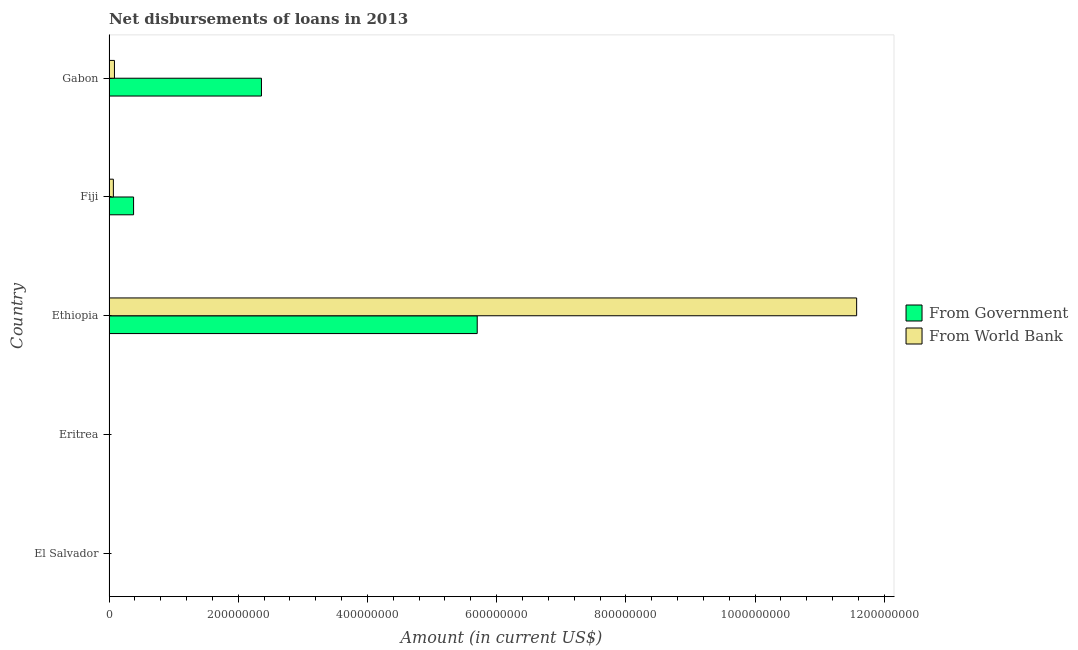Are the number of bars per tick equal to the number of legend labels?
Make the answer very short. No. Are the number of bars on each tick of the Y-axis equal?
Offer a very short reply. No. How many bars are there on the 3rd tick from the top?
Keep it short and to the point. 2. How many bars are there on the 1st tick from the bottom?
Provide a short and direct response. 0. What is the label of the 1st group of bars from the top?
Offer a very short reply. Gabon. In how many cases, is the number of bars for a given country not equal to the number of legend labels?
Your answer should be very brief. 2. Across all countries, what is the maximum net disbursements of loan from government?
Ensure brevity in your answer.  5.70e+08. In which country was the net disbursements of loan from world bank maximum?
Your answer should be compact. Ethiopia. What is the total net disbursements of loan from government in the graph?
Provide a short and direct response. 8.44e+08. What is the difference between the net disbursements of loan from world bank in Fiji and that in Gabon?
Provide a short and direct response. -1.68e+06. What is the difference between the net disbursements of loan from government in Fiji and the net disbursements of loan from world bank in Ethiopia?
Your response must be concise. -1.12e+09. What is the average net disbursements of loan from world bank per country?
Offer a terse response. 2.34e+08. What is the difference between the net disbursements of loan from world bank and net disbursements of loan from government in Ethiopia?
Give a very brief answer. 5.87e+08. What is the ratio of the net disbursements of loan from world bank in Fiji to that in Gabon?
Your answer should be very brief. 0.8. What is the difference between the highest and the second highest net disbursements of loan from world bank?
Ensure brevity in your answer.  1.15e+09. What is the difference between the highest and the lowest net disbursements of loan from government?
Your answer should be compact. 5.70e+08. In how many countries, is the net disbursements of loan from world bank greater than the average net disbursements of loan from world bank taken over all countries?
Keep it short and to the point. 1. Does the graph contain any zero values?
Provide a short and direct response. Yes. Does the graph contain grids?
Give a very brief answer. No. How many legend labels are there?
Provide a succinct answer. 2. What is the title of the graph?
Provide a succinct answer. Net disbursements of loans in 2013. What is the label or title of the Y-axis?
Keep it short and to the point. Country. What is the Amount (in current US$) in From Government in El Salvador?
Offer a terse response. 0. What is the Amount (in current US$) in From Government in Eritrea?
Provide a short and direct response. 0. What is the Amount (in current US$) of From World Bank in Eritrea?
Make the answer very short. 0. What is the Amount (in current US$) in From Government in Ethiopia?
Ensure brevity in your answer.  5.70e+08. What is the Amount (in current US$) in From World Bank in Ethiopia?
Provide a succinct answer. 1.16e+09. What is the Amount (in current US$) of From Government in Fiji?
Provide a short and direct response. 3.80e+07. What is the Amount (in current US$) of From World Bank in Fiji?
Your answer should be compact. 6.74e+06. What is the Amount (in current US$) in From Government in Gabon?
Give a very brief answer. 2.36e+08. What is the Amount (in current US$) in From World Bank in Gabon?
Your answer should be very brief. 8.42e+06. Across all countries, what is the maximum Amount (in current US$) of From Government?
Offer a very short reply. 5.70e+08. Across all countries, what is the maximum Amount (in current US$) in From World Bank?
Your answer should be compact. 1.16e+09. Across all countries, what is the minimum Amount (in current US$) in From Government?
Provide a short and direct response. 0. What is the total Amount (in current US$) of From Government in the graph?
Offer a very short reply. 8.44e+08. What is the total Amount (in current US$) in From World Bank in the graph?
Provide a short and direct response. 1.17e+09. What is the difference between the Amount (in current US$) in From Government in Ethiopia and that in Fiji?
Your answer should be compact. 5.32e+08. What is the difference between the Amount (in current US$) in From World Bank in Ethiopia and that in Fiji?
Provide a short and direct response. 1.15e+09. What is the difference between the Amount (in current US$) of From Government in Ethiopia and that in Gabon?
Your answer should be very brief. 3.34e+08. What is the difference between the Amount (in current US$) in From World Bank in Ethiopia and that in Gabon?
Ensure brevity in your answer.  1.15e+09. What is the difference between the Amount (in current US$) in From Government in Fiji and that in Gabon?
Your answer should be compact. -1.98e+08. What is the difference between the Amount (in current US$) in From World Bank in Fiji and that in Gabon?
Provide a succinct answer. -1.68e+06. What is the difference between the Amount (in current US$) in From Government in Ethiopia and the Amount (in current US$) in From World Bank in Fiji?
Provide a short and direct response. 5.63e+08. What is the difference between the Amount (in current US$) in From Government in Ethiopia and the Amount (in current US$) in From World Bank in Gabon?
Give a very brief answer. 5.62e+08. What is the difference between the Amount (in current US$) of From Government in Fiji and the Amount (in current US$) of From World Bank in Gabon?
Your answer should be compact. 2.96e+07. What is the average Amount (in current US$) of From Government per country?
Your answer should be very brief. 1.69e+08. What is the average Amount (in current US$) in From World Bank per country?
Ensure brevity in your answer.  2.34e+08. What is the difference between the Amount (in current US$) of From Government and Amount (in current US$) of From World Bank in Ethiopia?
Provide a short and direct response. -5.87e+08. What is the difference between the Amount (in current US$) in From Government and Amount (in current US$) in From World Bank in Fiji?
Your answer should be very brief. 3.13e+07. What is the difference between the Amount (in current US$) of From Government and Amount (in current US$) of From World Bank in Gabon?
Give a very brief answer. 2.28e+08. What is the ratio of the Amount (in current US$) of From Government in Ethiopia to that in Fiji?
Ensure brevity in your answer.  14.99. What is the ratio of the Amount (in current US$) in From World Bank in Ethiopia to that in Fiji?
Offer a terse response. 171.75. What is the ratio of the Amount (in current US$) in From Government in Ethiopia to that in Gabon?
Offer a terse response. 2.42. What is the ratio of the Amount (in current US$) in From World Bank in Ethiopia to that in Gabon?
Provide a short and direct response. 137.39. What is the ratio of the Amount (in current US$) of From Government in Fiji to that in Gabon?
Provide a short and direct response. 0.16. What is the difference between the highest and the second highest Amount (in current US$) in From Government?
Your answer should be very brief. 3.34e+08. What is the difference between the highest and the second highest Amount (in current US$) in From World Bank?
Keep it short and to the point. 1.15e+09. What is the difference between the highest and the lowest Amount (in current US$) in From Government?
Provide a succinct answer. 5.70e+08. What is the difference between the highest and the lowest Amount (in current US$) in From World Bank?
Offer a terse response. 1.16e+09. 